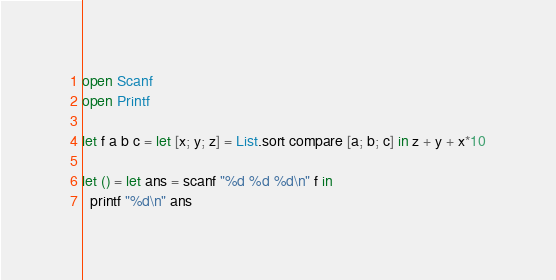<code> <loc_0><loc_0><loc_500><loc_500><_OCaml_>open Scanf
open Printf

let f a b c = let [x; y; z] = List.sort compare [a; b; c] in z + y + x*10

let () = let ans = scanf "%d %d %d\n" f in
  printf "%d\n" ans</code> 